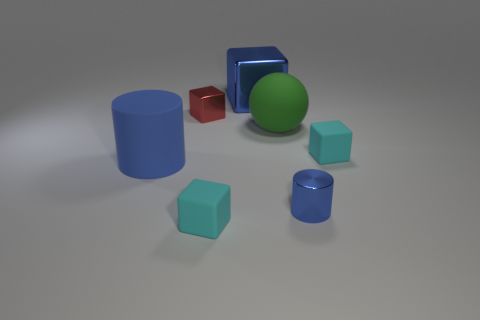What is the material of the tiny cube that is to the left of the small cyan object that is left of the blue metallic block behind the red metallic cube?
Make the answer very short. Metal. What number of other objects are the same size as the ball?
Provide a short and direct response. 2. There is a large object that is the same shape as the tiny red shiny object; what is its material?
Provide a short and direct response. Metal. What is the color of the big sphere?
Provide a short and direct response. Green. What is the color of the small rubber thing behind the rubber block on the left side of the big green rubber sphere?
Keep it short and to the point. Cyan. Is the color of the shiny cylinder the same as the small matte block on the left side of the sphere?
Your answer should be compact. No. What number of cyan matte cubes are right of the blue metallic thing behind the matte object that is left of the tiny red shiny thing?
Offer a very short reply. 1. Are there any tiny rubber things on the right side of the big blue shiny block?
Offer a terse response. Yes. Is there any other thing that has the same color as the shiny cylinder?
Offer a terse response. Yes. How many balls are either green things or large blue metallic things?
Offer a terse response. 1. 